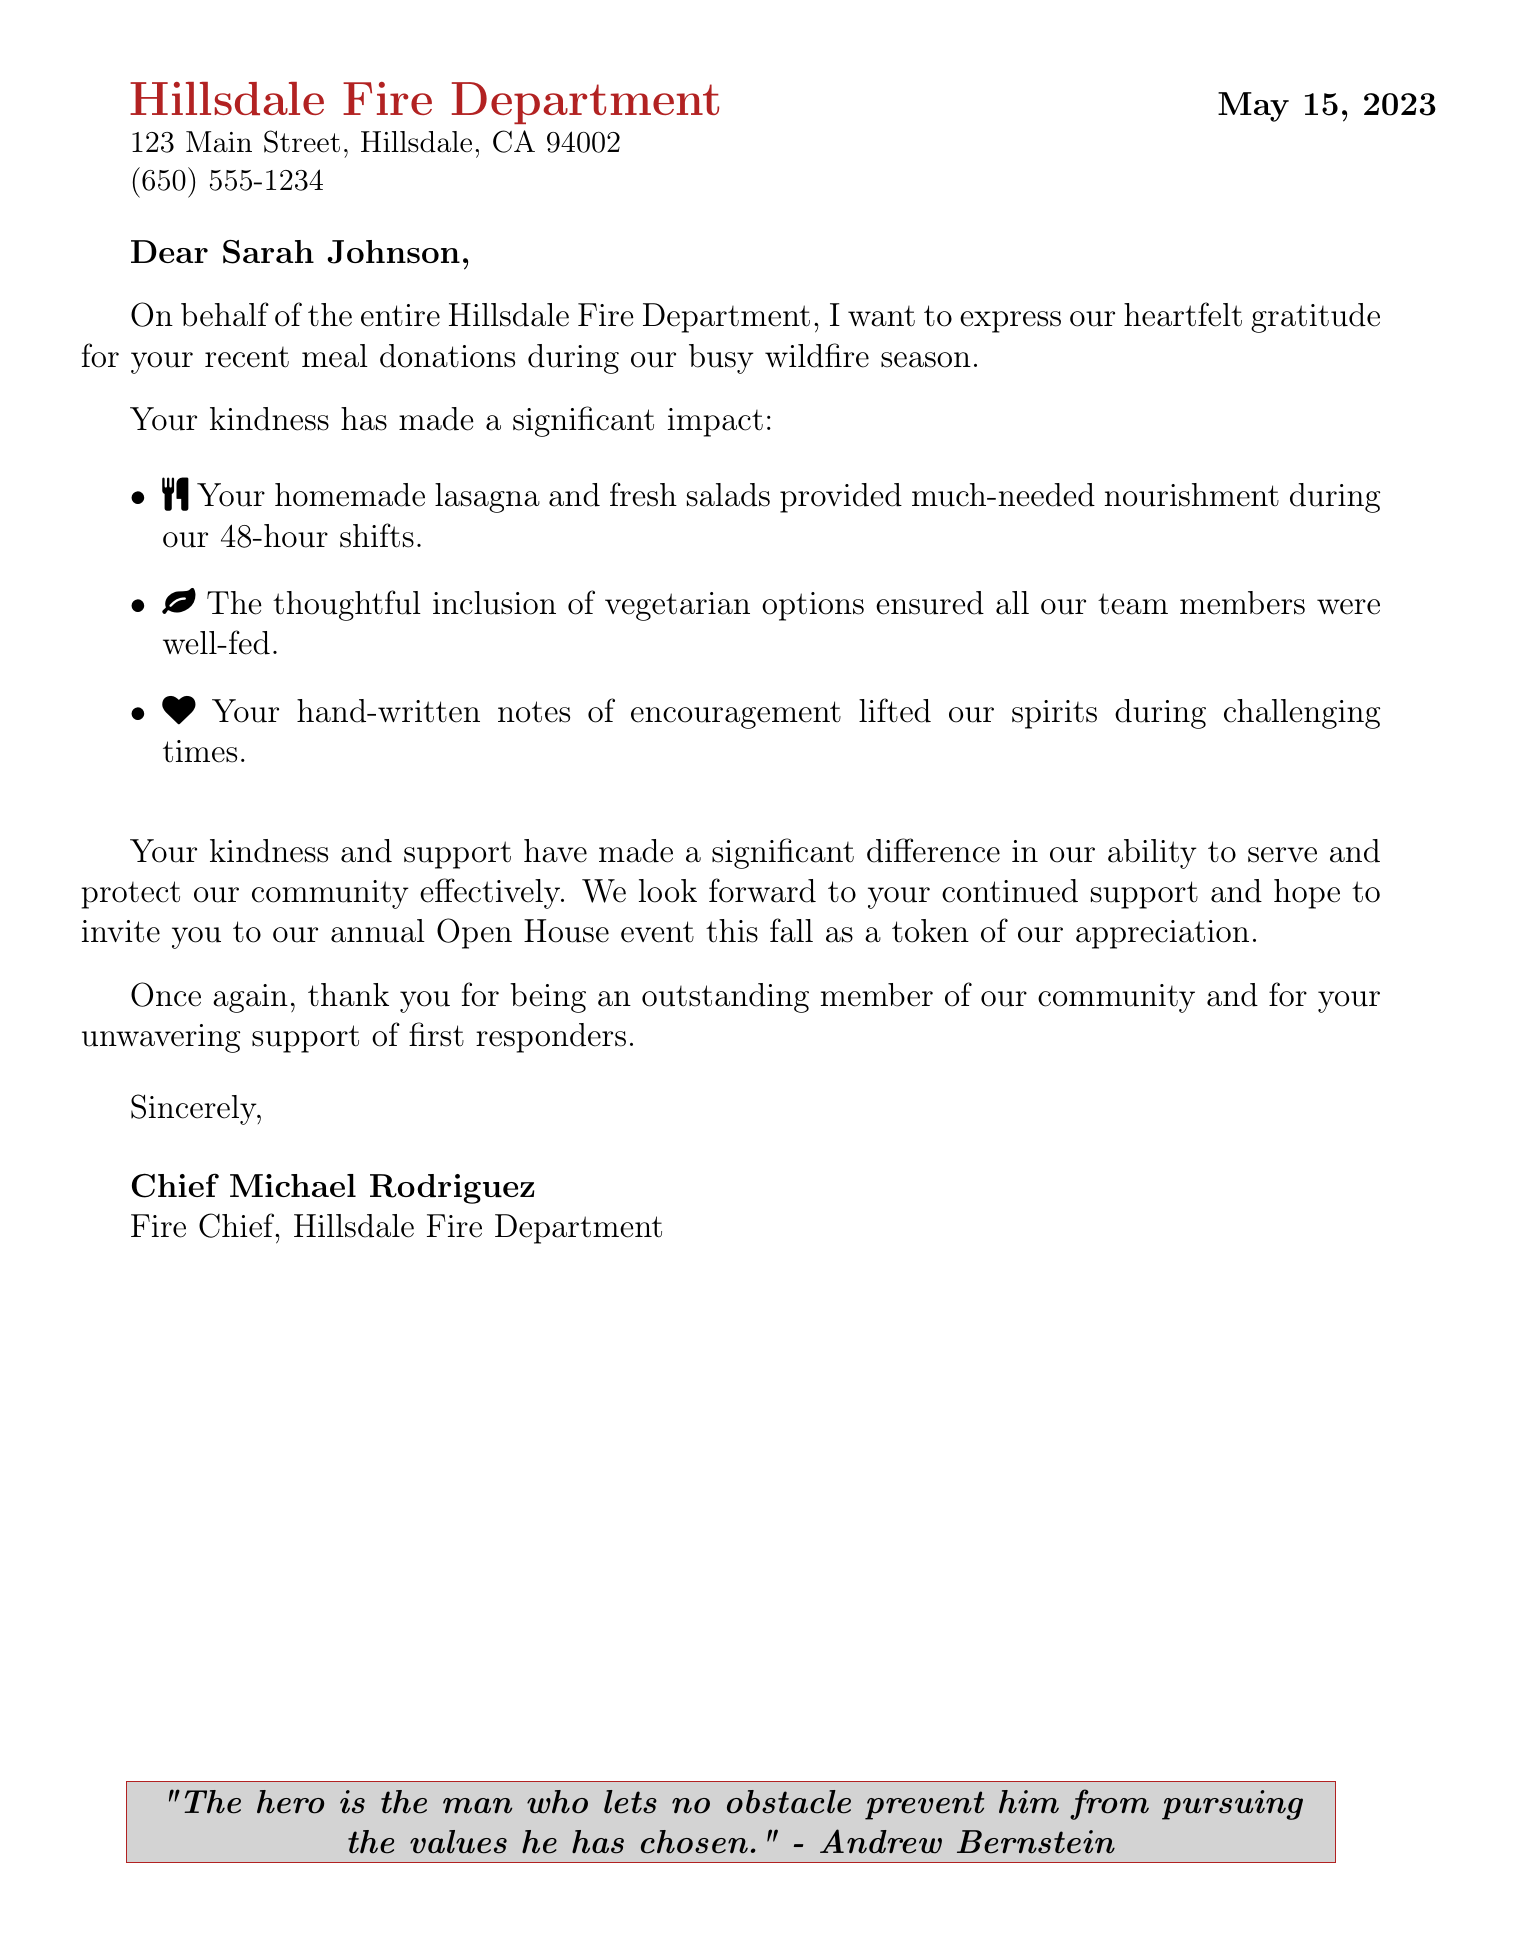What is the name of the department? The letterhead specifies the name of the department as Hillsdale Fire Department.
Answer: Hillsdale Fire Department What is the address of the Hillsdale Fire Department? The document lists the complete address in the letterhead section.
Answer: 123 Main Street, Hillsdale, CA 94002 Who is the letter addressed to? The salutation section states the name of the individual the letter is directed to.
Answer: Sarah Johnson What meal options were included in the donations? The specific details mention the types of meals provided, including vegetarian options.
Answer: Lasagna and fresh salads What date was the letter written? The document clearly states the date at the beginning.
Answer: May 15, 2023 Who signed the letter? The signature section provides the name of the person who authored the letter.
Answer: Chief Michael Rodriguez What is the primary reason for the letter? The opening paragraph expresses the main purpose of the letter.
Answer: Gratitude for meal donations What kind of event is mentioned for future appreciation? The future appreciation section indicates an upcoming event related to expressing thanks.
Answer: Annual Open House event How did Sarah Johnson's notes impact the first responders? The specific details highlight the emotional effect of the notes on the team.
Answer: Lifted our spirits 